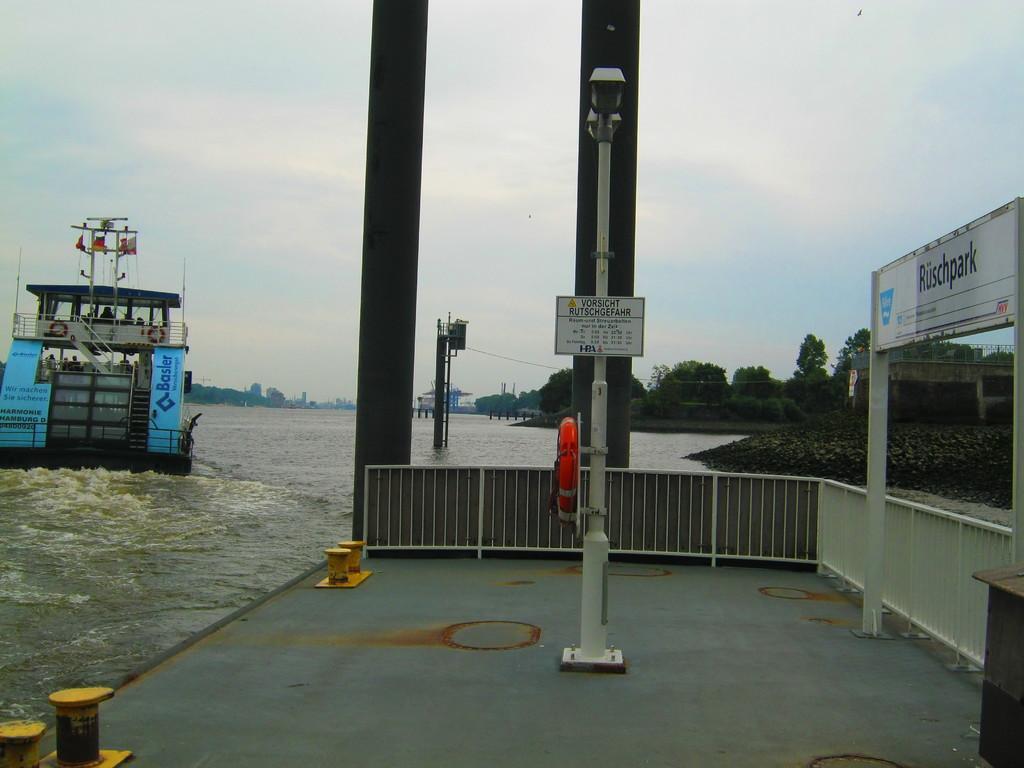Could you give a brief overview of what you see in this image? In this image, we can see poles, boards, railing and path. In the background, we can see poles, trees, water and sky. On the left side of the image, we can see a ship is above the water. 